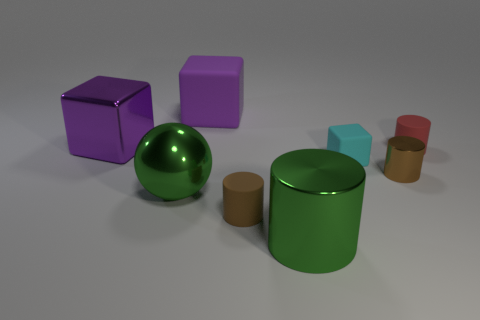Add 2 tiny green cylinders. How many objects exist? 10 Subtract all small blocks. How many blocks are left? 2 Subtract 1 green balls. How many objects are left? 7 Subtract all cubes. How many objects are left? 5 Subtract 1 cylinders. How many cylinders are left? 3 Subtract all blue cubes. Subtract all green spheres. How many cubes are left? 3 Subtract all red cubes. How many red cylinders are left? 1 Subtract all tiny brown metal things. Subtract all small brown shiny things. How many objects are left? 6 Add 2 purple rubber cubes. How many purple rubber cubes are left? 3 Add 7 brown cylinders. How many brown cylinders exist? 9 